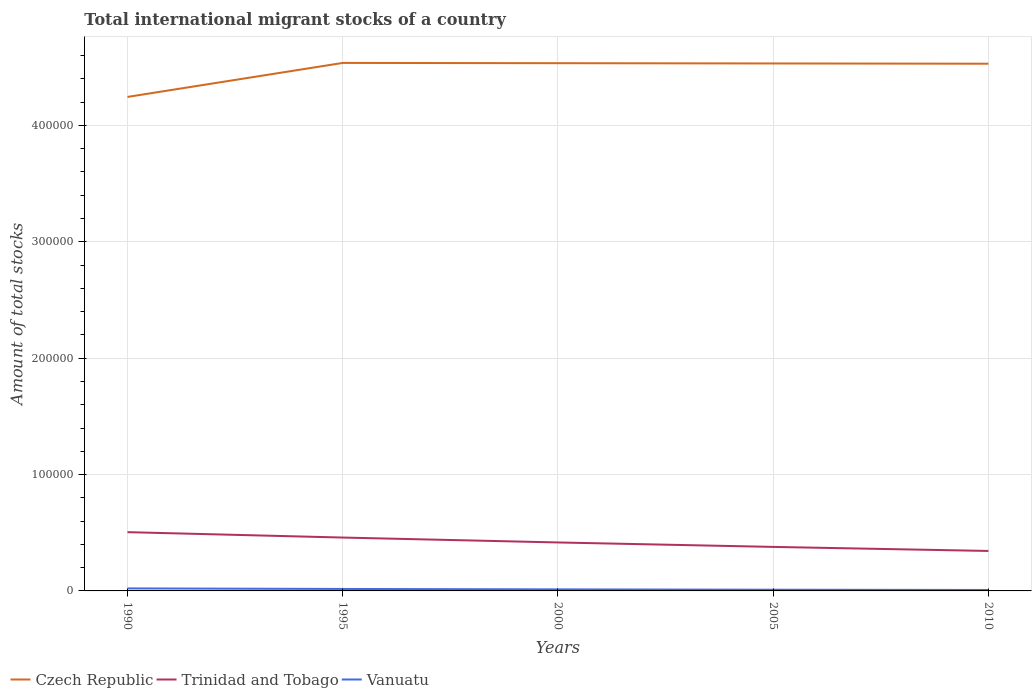How many different coloured lines are there?
Your answer should be compact. 3. Does the line corresponding to Trinidad and Tobago intersect with the line corresponding to Vanuatu?
Your response must be concise. No. Is the number of lines equal to the number of legend labels?
Offer a terse response. Yes. Across all years, what is the maximum amount of total stocks in in Trinidad and Tobago?
Ensure brevity in your answer.  3.43e+04. In which year was the amount of total stocks in in Trinidad and Tobago maximum?
Ensure brevity in your answer.  2010. What is the total amount of total stocks in in Vanuatu in the graph?
Your response must be concise. 876. What is the difference between the highest and the second highest amount of total stocks in in Czech Republic?
Offer a very short reply. 2.92e+04. Is the amount of total stocks in in Czech Republic strictly greater than the amount of total stocks in in Vanuatu over the years?
Ensure brevity in your answer.  No. Are the values on the major ticks of Y-axis written in scientific E-notation?
Your answer should be very brief. No. Does the graph contain any zero values?
Make the answer very short. No. Does the graph contain grids?
Your response must be concise. Yes. How are the legend labels stacked?
Your answer should be compact. Horizontal. What is the title of the graph?
Give a very brief answer. Total international migrant stocks of a country. What is the label or title of the Y-axis?
Your answer should be very brief. Amount of total stocks. What is the Amount of total stocks of Czech Republic in 1990?
Provide a short and direct response. 4.24e+05. What is the Amount of total stocks of Trinidad and Tobago in 1990?
Provide a short and direct response. 5.05e+04. What is the Amount of total stocks of Vanuatu in 1990?
Offer a terse response. 2157. What is the Amount of total stocks of Czech Republic in 1995?
Your answer should be compact. 4.54e+05. What is the Amount of total stocks in Trinidad and Tobago in 1995?
Provide a succinct answer. 4.59e+04. What is the Amount of total stocks in Vanuatu in 1995?
Provide a succinct answer. 1690. What is the Amount of total stocks in Czech Republic in 2000?
Provide a short and direct response. 4.53e+05. What is the Amount of total stocks of Trinidad and Tobago in 2000?
Keep it short and to the point. 4.16e+04. What is the Amount of total stocks in Vanuatu in 2000?
Offer a very short reply. 1325. What is the Amount of total stocks in Czech Republic in 2005?
Your answer should be compact. 4.53e+05. What is the Amount of total stocks in Trinidad and Tobago in 2005?
Ensure brevity in your answer.  3.78e+04. What is the Amount of total stocks of Vanuatu in 2005?
Offer a terse response. 1038. What is the Amount of total stocks of Czech Republic in 2010?
Provide a succinct answer. 4.53e+05. What is the Amount of total stocks of Trinidad and Tobago in 2010?
Your answer should be compact. 3.43e+04. What is the Amount of total stocks of Vanuatu in 2010?
Offer a very short reply. 814. Across all years, what is the maximum Amount of total stocks of Czech Republic?
Your answer should be compact. 4.54e+05. Across all years, what is the maximum Amount of total stocks in Trinidad and Tobago?
Your answer should be compact. 5.05e+04. Across all years, what is the maximum Amount of total stocks in Vanuatu?
Provide a short and direct response. 2157. Across all years, what is the minimum Amount of total stocks in Czech Republic?
Your response must be concise. 4.24e+05. Across all years, what is the minimum Amount of total stocks of Trinidad and Tobago?
Offer a very short reply. 3.43e+04. Across all years, what is the minimum Amount of total stocks of Vanuatu?
Offer a very short reply. 814. What is the total Amount of total stocks of Czech Republic in the graph?
Provide a short and direct response. 2.24e+06. What is the total Amount of total stocks in Trinidad and Tobago in the graph?
Ensure brevity in your answer.  2.10e+05. What is the total Amount of total stocks in Vanuatu in the graph?
Provide a succinct answer. 7024. What is the difference between the Amount of total stocks in Czech Republic in 1990 and that in 1995?
Offer a very short reply. -2.92e+04. What is the difference between the Amount of total stocks of Trinidad and Tobago in 1990 and that in 1995?
Make the answer very short. 4640. What is the difference between the Amount of total stocks of Vanuatu in 1990 and that in 1995?
Keep it short and to the point. 467. What is the difference between the Amount of total stocks in Czech Republic in 1990 and that in 2000?
Keep it short and to the point. -2.90e+04. What is the difference between the Amount of total stocks of Trinidad and Tobago in 1990 and that in 2000?
Provide a short and direct response. 8854. What is the difference between the Amount of total stocks in Vanuatu in 1990 and that in 2000?
Provide a short and direct response. 832. What is the difference between the Amount of total stocks in Czech Republic in 1990 and that in 2005?
Keep it short and to the point. -2.88e+04. What is the difference between the Amount of total stocks of Trinidad and Tobago in 1990 and that in 2005?
Offer a terse response. 1.27e+04. What is the difference between the Amount of total stocks of Vanuatu in 1990 and that in 2005?
Provide a short and direct response. 1119. What is the difference between the Amount of total stocks of Czech Republic in 1990 and that in 2010?
Provide a short and direct response. -2.85e+04. What is the difference between the Amount of total stocks of Trinidad and Tobago in 1990 and that in 2010?
Offer a very short reply. 1.62e+04. What is the difference between the Amount of total stocks in Vanuatu in 1990 and that in 2010?
Your response must be concise. 1343. What is the difference between the Amount of total stocks of Czech Republic in 1995 and that in 2000?
Keep it short and to the point. 224. What is the difference between the Amount of total stocks of Trinidad and Tobago in 1995 and that in 2000?
Make the answer very short. 4214. What is the difference between the Amount of total stocks of Vanuatu in 1995 and that in 2000?
Ensure brevity in your answer.  365. What is the difference between the Amount of total stocks in Czech Republic in 1995 and that in 2005?
Give a very brief answer. 448. What is the difference between the Amount of total stocks in Trinidad and Tobago in 1995 and that in 2005?
Provide a succinct answer. 8041. What is the difference between the Amount of total stocks of Vanuatu in 1995 and that in 2005?
Keep it short and to the point. 652. What is the difference between the Amount of total stocks of Czech Republic in 1995 and that in 2010?
Ensure brevity in your answer.  672. What is the difference between the Amount of total stocks of Trinidad and Tobago in 1995 and that in 2010?
Provide a short and direct response. 1.15e+04. What is the difference between the Amount of total stocks in Vanuatu in 1995 and that in 2010?
Your response must be concise. 876. What is the difference between the Amount of total stocks in Czech Republic in 2000 and that in 2005?
Give a very brief answer. 224. What is the difference between the Amount of total stocks of Trinidad and Tobago in 2000 and that in 2005?
Ensure brevity in your answer.  3827. What is the difference between the Amount of total stocks in Vanuatu in 2000 and that in 2005?
Offer a terse response. 287. What is the difference between the Amount of total stocks of Czech Republic in 2000 and that in 2010?
Your answer should be compact. 448. What is the difference between the Amount of total stocks in Trinidad and Tobago in 2000 and that in 2010?
Offer a very short reply. 7302. What is the difference between the Amount of total stocks of Vanuatu in 2000 and that in 2010?
Give a very brief answer. 511. What is the difference between the Amount of total stocks of Czech Republic in 2005 and that in 2010?
Your answer should be very brief. 224. What is the difference between the Amount of total stocks of Trinidad and Tobago in 2005 and that in 2010?
Make the answer very short. 3475. What is the difference between the Amount of total stocks of Vanuatu in 2005 and that in 2010?
Offer a terse response. 224. What is the difference between the Amount of total stocks in Czech Republic in 1990 and the Amount of total stocks in Trinidad and Tobago in 1995?
Make the answer very short. 3.79e+05. What is the difference between the Amount of total stocks of Czech Republic in 1990 and the Amount of total stocks of Vanuatu in 1995?
Ensure brevity in your answer.  4.23e+05. What is the difference between the Amount of total stocks in Trinidad and Tobago in 1990 and the Amount of total stocks in Vanuatu in 1995?
Make the answer very short. 4.88e+04. What is the difference between the Amount of total stocks of Czech Republic in 1990 and the Amount of total stocks of Trinidad and Tobago in 2000?
Provide a short and direct response. 3.83e+05. What is the difference between the Amount of total stocks of Czech Republic in 1990 and the Amount of total stocks of Vanuatu in 2000?
Give a very brief answer. 4.23e+05. What is the difference between the Amount of total stocks of Trinidad and Tobago in 1990 and the Amount of total stocks of Vanuatu in 2000?
Make the answer very short. 4.92e+04. What is the difference between the Amount of total stocks of Czech Republic in 1990 and the Amount of total stocks of Trinidad and Tobago in 2005?
Offer a terse response. 3.87e+05. What is the difference between the Amount of total stocks in Czech Republic in 1990 and the Amount of total stocks in Vanuatu in 2005?
Offer a terse response. 4.23e+05. What is the difference between the Amount of total stocks of Trinidad and Tobago in 1990 and the Amount of total stocks of Vanuatu in 2005?
Provide a succinct answer. 4.95e+04. What is the difference between the Amount of total stocks of Czech Republic in 1990 and the Amount of total stocks of Trinidad and Tobago in 2010?
Provide a succinct answer. 3.90e+05. What is the difference between the Amount of total stocks of Czech Republic in 1990 and the Amount of total stocks of Vanuatu in 2010?
Provide a succinct answer. 4.24e+05. What is the difference between the Amount of total stocks of Trinidad and Tobago in 1990 and the Amount of total stocks of Vanuatu in 2010?
Your response must be concise. 4.97e+04. What is the difference between the Amount of total stocks of Czech Republic in 1995 and the Amount of total stocks of Trinidad and Tobago in 2000?
Offer a very short reply. 4.12e+05. What is the difference between the Amount of total stocks in Czech Republic in 1995 and the Amount of total stocks in Vanuatu in 2000?
Make the answer very short. 4.52e+05. What is the difference between the Amount of total stocks of Trinidad and Tobago in 1995 and the Amount of total stocks of Vanuatu in 2000?
Offer a terse response. 4.45e+04. What is the difference between the Amount of total stocks in Czech Republic in 1995 and the Amount of total stocks in Trinidad and Tobago in 2005?
Keep it short and to the point. 4.16e+05. What is the difference between the Amount of total stocks in Czech Republic in 1995 and the Amount of total stocks in Vanuatu in 2005?
Provide a short and direct response. 4.53e+05. What is the difference between the Amount of total stocks in Trinidad and Tobago in 1995 and the Amount of total stocks in Vanuatu in 2005?
Provide a succinct answer. 4.48e+04. What is the difference between the Amount of total stocks in Czech Republic in 1995 and the Amount of total stocks in Trinidad and Tobago in 2010?
Make the answer very short. 4.19e+05. What is the difference between the Amount of total stocks in Czech Republic in 1995 and the Amount of total stocks in Vanuatu in 2010?
Keep it short and to the point. 4.53e+05. What is the difference between the Amount of total stocks of Trinidad and Tobago in 1995 and the Amount of total stocks of Vanuatu in 2010?
Your answer should be very brief. 4.50e+04. What is the difference between the Amount of total stocks of Czech Republic in 2000 and the Amount of total stocks of Trinidad and Tobago in 2005?
Provide a short and direct response. 4.16e+05. What is the difference between the Amount of total stocks of Czech Republic in 2000 and the Amount of total stocks of Vanuatu in 2005?
Provide a short and direct response. 4.52e+05. What is the difference between the Amount of total stocks in Trinidad and Tobago in 2000 and the Amount of total stocks in Vanuatu in 2005?
Ensure brevity in your answer.  4.06e+04. What is the difference between the Amount of total stocks of Czech Republic in 2000 and the Amount of total stocks of Trinidad and Tobago in 2010?
Provide a short and direct response. 4.19e+05. What is the difference between the Amount of total stocks in Czech Republic in 2000 and the Amount of total stocks in Vanuatu in 2010?
Your answer should be very brief. 4.53e+05. What is the difference between the Amount of total stocks in Trinidad and Tobago in 2000 and the Amount of total stocks in Vanuatu in 2010?
Your answer should be very brief. 4.08e+04. What is the difference between the Amount of total stocks in Czech Republic in 2005 and the Amount of total stocks in Trinidad and Tobago in 2010?
Your answer should be compact. 4.19e+05. What is the difference between the Amount of total stocks in Czech Republic in 2005 and the Amount of total stocks in Vanuatu in 2010?
Your answer should be very brief. 4.52e+05. What is the difference between the Amount of total stocks in Trinidad and Tobago in 2005 and the Amount of total stocks in Vanuatu in 2010?
Your answer should be compact. 3.70e+04. What is the average Amount of total stocks in Czech Republic per year?
Your answer should be compact. 4.48e+05. What is the average Amount of total stocks in Trinidad and Tobago per year?
Offer a very short reply. 4.20e+04. What is the average Amount of total stocks of Vanuatu per year?
Your answer should be compact. 1404.8. In the year 1990, what is the difference between the Amount of total stocks of Czech Republic and Amount of total stocks of Trinidad and Tobago?
Your response must be concise. 3.74e+05. In the year 1990, what is the difference between the Amount of total stocks in Czech Republic and Amount of total stocks in Vanuatu?
Keep it short and to the point. 4.22e+05. In the year 1990, what is the difference between the Amount of total stocks of Trinidad and Tobago and Amount of total stocks of Vanuatu?
Ensure brevity in your answer.  4.83e+04. In the year 1995, what is the difference between the Amount of total stocks in Czech Republic and Amount of total stocks in Trinidad and Tobago?
Offer a very short reply. 4.08e+05. In the year 1995, what is the difference between the Amount of total stocks in Czech Republic and Amount of total stocks in Vanuatu?
Ensure brevity in your answer.  4.52e+05. In the year 1995, what is the difference between the Amount of total stocks in Trinidad and Tobago and Amount of total stocks in Vanuatu?
Ensure brevity in your answer.  4.42e+04. In the year 2000, what is the difference between the Amount of total stocks of Czech Republic and Amount of total stocks of Trinidad and Tobago?
Make the answer very short. 4.12e+05. In the year 2000, what is the difference between the Amount of total stocks in Czech Republic and Amount of total stocks in Vanuatu?
Provide a succinct answer. 4.52e+05. In the year 2000, what is the difference between the Amount of total stocks of Trinidad and Tobago and Amount of total stocks of Vanuatu?
Keep it short and to the point. 4.03e+04. In the year 2005, what is the difference between the Amount of total stocks in Czech Republic and Amount of total stocks in Trinidad and Tobago?
Ensure brevity in your answer.  4.15e+05. In the year 2005, what is the difference between the Amount of total stocks in Czech Republic and Amount of total stocks in Vanuatu?
Your response must be concise. 4.52e+05. In the year 2005, what is the difference between the Amount of total stocks in Trinidad and Tobago and Amount of total stocks in Vanuatu?
Offer a terse response. 3.68e+04. In the year 2010, what is the difference between the Amount of total stocks in Czech Republic and Amount of total stocks in Trinidad and Tobago?
Provide a short and direct response. 4.19e+05. In the year 2010, what is the difference between the Amount of total stocks of Czech Republic and Amount of total stocks of Vanuatu?
Make the answer very short. 4.52e+05. In the year 2010, what is the difference between the Amount of total stocks in Trinidad and Tobago and Amount of total stocks in Vanuatu?
Your answer should be compact. 3.35e+04. What is the ratio of the Amount of total stocks in Czech Republic in 1990 to that in 1995?
Your response must be concise. 0.94. What is the ratio of the Amount of total stocks of Trinidad and Tobago in 1990 to that in 1995?
Provide a succinct answer. 1.1. What is the ratio of the Amount of total stocks of Vanuatu in 1990 to that in 1995?
Your answer should be very brief. 1.28. What is the ratio of the Amount of total stocks in Czech Republic in 1990 to that in 2000?
Offer a terse response. 0.94. What is the ratio of the Amount of total stocks of Trinidad and Tobago in 1990 to that in 2000?
Your response must be concise. 1.21. What is the ratio of the Amount of total stocks of Vanuatu in 1990 to that in 2000?
Your answer should be very brief. 1.63. What is the ratio of the Amount of total stocks in Czech Republic in 1990 to that in 2005?
Ensure brevity in your answer.  0.94. What is the ratio of the Amount of total stocks in Trinidad and Tobago in 1990 to that in 2005?
Keep it short and to the point. 1.34. What is the ratio of the Amount of total stocks in Vanuatu in 1990 to that in 2005?
Keep it short and to the point. 2.08. What is the ratio of the Amount of total stocks in Czech Republic in 1990 to that in 2010?
Offer a terse response. 0.94. What is the ratio of the Amount of total stocks of Trinidad and Tobago in 1990 to that in 2010?
Ensure brevity in your answer.  1.47. What is the ratio of the Amount of total stocks in Vanuatu in 1990 to that in 2010?
Provide a succinct answer. 2.65. What is the ratio of the Amount of total stocks of Czech Republic in 1995 to that in 2000?
Give a very brief answer. 1. What is the ratio of the Amount of total stocks of Trinidad and Tobago in 1995 to that in 2000?
Provide a short and direct response. 1.1. What is the ratio of the Amount of total stocks of Vanuatu in 1995 to that in 2000?
Keep it short and to the point. 1.28. What is the ratio of the Amount of total stocks of Trinidad and Tobago in 1995 to that in 2005?
Provide a succinct answer. 1.21. What is the ratio of the Amount of total stocks of Vanuatu in 1995 to that in 2005?
Keep it short and to the point. 1.63. What is the ratio of the Amount of total stocks in Czech Republic in 1995 to that in 2010?
Provide a succinct answer. 1. What is the ratio of the Amount of total stocks of Trinidad and Tobago in 1995 to that in 2010?
Your answer should be compact. 1.34. What is the ratio of the Amount of total stocks in Vanuatu in 1995 to that in 2010?
Give a very brief answer. 2.08. What is the ratio of the Amount of total stocks in Trinidad and Tobago in 2000 to that in 2005?
Provide a short and direct response. 1.1. What is the ratio of the Amount of total stocks of Vanuatu in 2000 to that in 2005?
Provide a short and direct response. 1.28. What is the ratio of the Amount of total stocks in Czech Republic in 2000 to that in 2010?
Provide a short and direct response. 1. What is the ratio of the Amount of total stocks in Trinidad and Tobago in 2000 to that in 2010?
Offer a terse response. 1.21. What is the ratio of the Amount of total stocks in Vanuatu in 2000 to that in 2010?
Your answer should be very brief. 1.63. What is the ratio of the Amount of total stocks in Trinidad and Tobago in 2005 to that in 2010?
Ensure brevity in your answer.  1.1. What is the ratio of the Amount of total stocks in Vanuatu in 2005 to that in 2010?
Keep it short and to the point. 1.28. What is the difference between the highest and the second highest Amount of total stocks in Czech Republic?
Your response must be concise. 224. What is the difference between the highest and the second highest Amount of total stocks in Trinidad and Tobago?
Offer a very short reply. 4640. What is the difference between the highest and the second highest Amount of total stocks of Vanuatu?
Ensure brevity in your answer.  467. What is the difference between the highest and the lowest Amount of total stocks of Czech Republic?
Your response must be concise. 2.92e+04. What is the difference between the highest and the lowest Amount of total stocks of Trinidad and Tobago?
Give a very brief answer. 1.62e+04. What is the difference between the highest and the lowest Amount of total stocks of Vanuatu?
Give a very brief answer. 1343. 